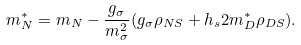<formula> <loc_0><loc_0><loc_500><loc_500>m _ { N } ^ { * } = m _ { N } - \frac { g _ { \sigma } } { m _ { \sigma } ^ { 2 } } ( g _ { \sigma } \rho _ { N S } + h _ { s } 2 m _ { D } ^ { * } \rho _ { D S } ) .</formula> 